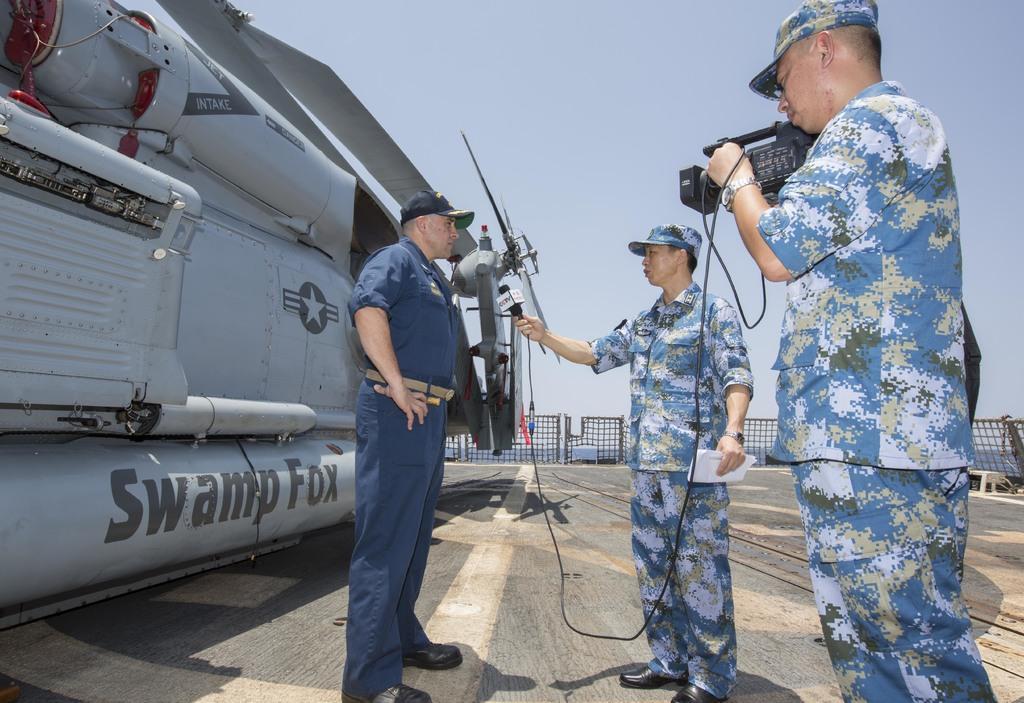Can you describe this image briefly? In the background we can see sky, railings. We can see two men in the same attire wearing caps. Among them one is holding a video recorder and other is holding a mike in one hand and papers in the other hand. We can see another man standing, wearing a cap. 